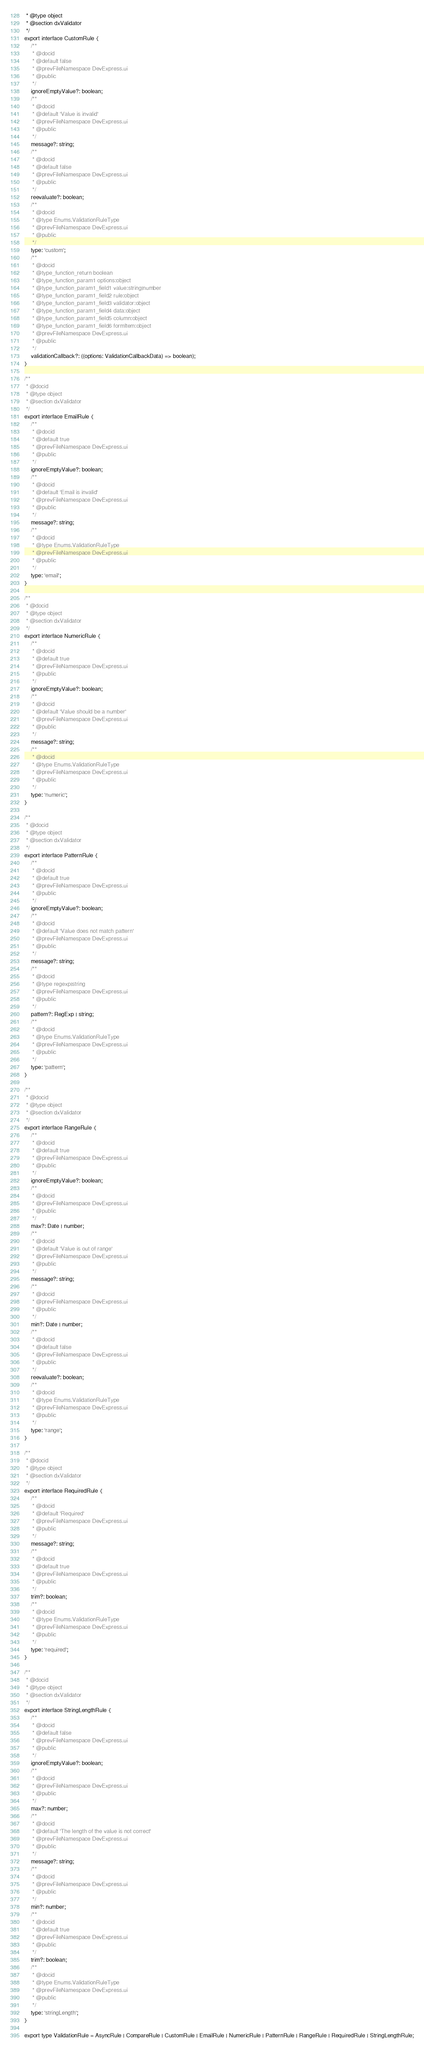Convert code to text. <code><loc_0><loc_0><loc_500><loc_500><_TypeScript_> * @type object
 * @section dxValidator
 */
export interface CustomRule {
    /**
     * @docid
     * @default false
     * @prevFileNamespace DevExpress.ui
     * @public
     */
    ignoreEmptyValue?: boolean;
    /**
     * @docid
     * @default 'Value is invalid'
     * @prevFileNamespace DevExpress.ui
     * @public
     */
    message?: string;
    /**
     * @docid
     * @default false
     * @prevFileNamespace DevExpress.ui
     * @public
     */
    reevaluate?: boolean;
    /**
     * @docid
     * @type Enums.ValidationRuleType
     * @prevFileNamespace DevExpress.ui
     * @public
     */
    type: 'custom';
    /**
     * @docid
     * @type_function_return boolean
     * @type_function_param1 options:object
     * @type_function_param1_field1 value:string|number
     * @type_function_param1_field2 rule:object
     * @type_function_param1_field3 validator:object
     * @type_function_param1_field4 data:object
     * @type_function_param1_field5 column:object
     * @type_function_param1_field6 formItem:object
     * @prevFileNamespace DevExpress.ui
     * @public
     */
    validationCallback?: ((options: ValidationCallbackData) => boolean);
}

/**
 * @docid
 * @type object
 * @section dxValidator
 */
export interface EmailRule {
    /**
     * @docid
     * @default true
     * @prevFileNamespace DevExpress.ui
     * @public
     */
    ignoreEmptyValue?: boolean;
    /**
     * @docid
     * @default 'Email is invalid'
     * @prevFileNamespace DevExpress.ui
     * @public
     */
    message?: string;
    /**
     * @docid
     * @type Enums.ValidationRuleType
     * @prevFileNamespace DevExpress.ui
     * @public
     */
    type: 'email';
}

/**
 * @docid
 * @type object
 * @section dxValidator
 */
export interface NumericRule {
    /**
     * @docid
     * @default true
     * @prevFileNamespace DevExpress.ui
     * @public
     */
    ignoreEmptyValue?: boolean;
    /**
     * @docid
     * @default 'Value should be a number'
     * @prevFileNamespace DevExpress.ui
     * @public
     */
    message?: string;
    /**
     * @docid
     * @type Enums.ValidationRuleType
     * @prevFileNamespace DevExpress.ui
     * @public
     */
    type: 'numeric';
}

/**
 * @docid
 * @type object
 * @section dxValidator
 */
export interface PatternRule {
    /**
     * @docid
     * @default true
     * @prevFileNamespace DevExpress.ui
     * @public
     */
    ignoreEmptyValue?: boolean;
    /**
     * @docid
     * @default 'Value does not match pattern'
     * @prevFileNamespace DevExpress.ui
     * @public
     */
    message?: string;
    /**
     * @docid
     * @type regexp|string
     * @prevFileNamespace DevExpress.ui
     * @public
     */
    pattern?: RegExp | string;
    /**
     * @docid
     * @type Enums.ValidationRuleType
     * @prevFileNamespace DevExpress.ui
     * @public
     */
    type: 'pattern';
}

/**
 * @docid
 * @type object
 * @section dxValidator
 */
export interface RangeRule {
    /**
     * @docid
     * @default true
     * @prevFileNamespace DevExpress.ui
     * @public
     */
    ignoreEmptyValue?: boolean;
    /**
     * @docid
     * @prevFileNamespace DevExpress.ui
     * @public
     */
    max?: Date | number;
    /**
     * @docid
     * @default 'Value is out of range'
     * @prevFileNamespace DevExpress.ui
     * @public
     */
    message?: string;
    /**
     * @docid
     * @prevFileNamespace DevExpress.ui
     * @public
     */
    min?: Date | number;
    /**
     * @docid
     * @default false
     * @prevFileNamespace DevExpress.ui
     * @public
     */
    reevaluate?: boolean;
    /**
     * @docid
     * @type Enums.ValidationRuleType
     * @prevFileNamespace DevExpress.ui
     * @public
     */
    type: 'range';
}

/**
 * @docid
 * @type object
 * @section dxValidator
 */
export interface RequiredRule {
    /**
     * @docid
     * @default 'Required'
     * @prevFileNamespace DevExpress.ui
     * @public
     */
    message?: string;
    /**
     * @docid
     * @default true
     * @prevFileNamespace DevExpress.ui
     * @public
     */
    trim?: boolean;
    /**
     * @docid
     * @type Enums.ValidationRuleType
     * @prevFileNamespace DevExpress.ui
     * @public
     */
    type: 'required';
}

/**
 * @docid
 * @type object
 * @section dxValidator
 */
export interface StringLengthRule {
    /**
     * @docid
     * @default false
     * @prevFileNamespace DevExpress.ui
     * @public
     */
    ignoreEmptyValue?: boolean;
    /**
     * @docid
     * @prevFileNamespace DevExpress.ui
     * @public
     */
    max?: number;
    /**
     * @docid
     * @default 'The length of the value is not correct'
     * @prevFileNamespace DevExpress.ui
     * @public
     */
    message?: string;
    /**
     * @docid
     * @prevFileNamespace DevExpress.ui
     * @public
     */
    min?: number;
    /**
     * @docid
     * @default true
     * @prevFileNamespace DevExpress.ui
     * @public
     */
    trim?: boolean;
    /**
     * @docid
     * @type Enums.ValidationRuleType
     * @prevFileNamespace DevExpress.ui
     * @public
     */
    type: 'stringLength';
}

export type ValidationRule = AsyncRule | CompareRule | CustomRule | EmailRule | NumericRule | PatternRule | RangeRule | RequiredRule | StringLengthRule;
</code> 